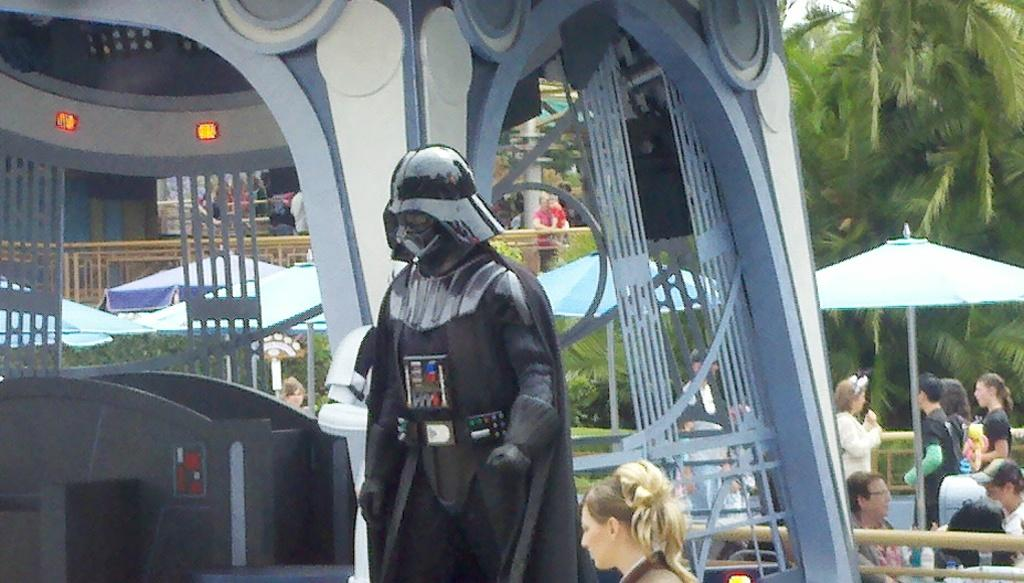What is the main subject in the image? There is a black statue in the image. What can be seen in the background of the image? There are trees, people, and umbrellas in the background of the image. How many ladybugs can be seen on the statue in the image? There are no ladybugs present on the statue or in the image. What type of car is parked near the statue in the image? There is no car present in the image. 